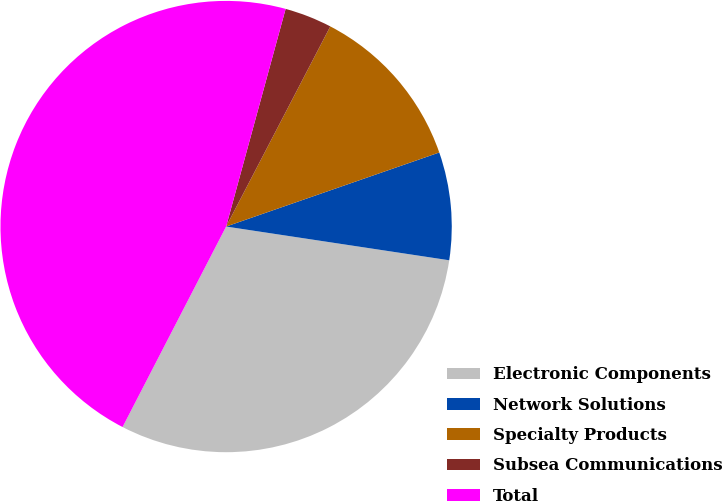Convert chart. <chart><loc_0><loc_0><loc_500><loc_500><pie_chart><fcel>Electronic Components<fcel>Network Solutions<fcel>Specialty Products<fcel>Subsea Communications<fcel>Total<nl><fcel>30.2%<fcel>7.71%<fcel>12.04%<fcel>3.39%<fcel>46.66%<nl></chart> 